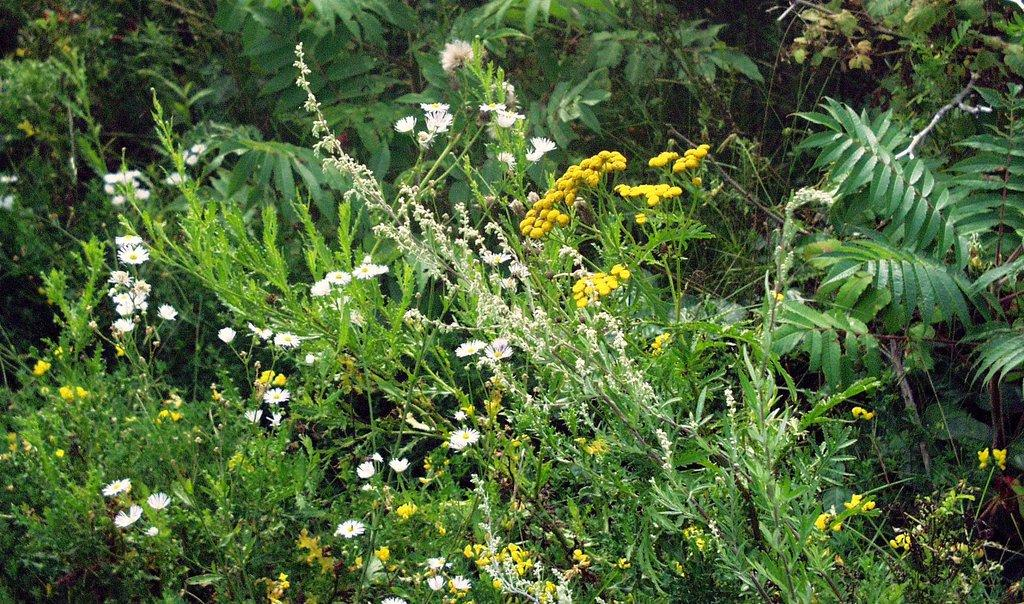What type of vegetation can be seen in the image? There are flowers on plants and trees present in the image. Can you describe the trees in the image? The trees in the image are part of the natural landscape. How many pigs are tied to the square-shaped string in the image? There are no pigs or square-shaped strings present in the image. 